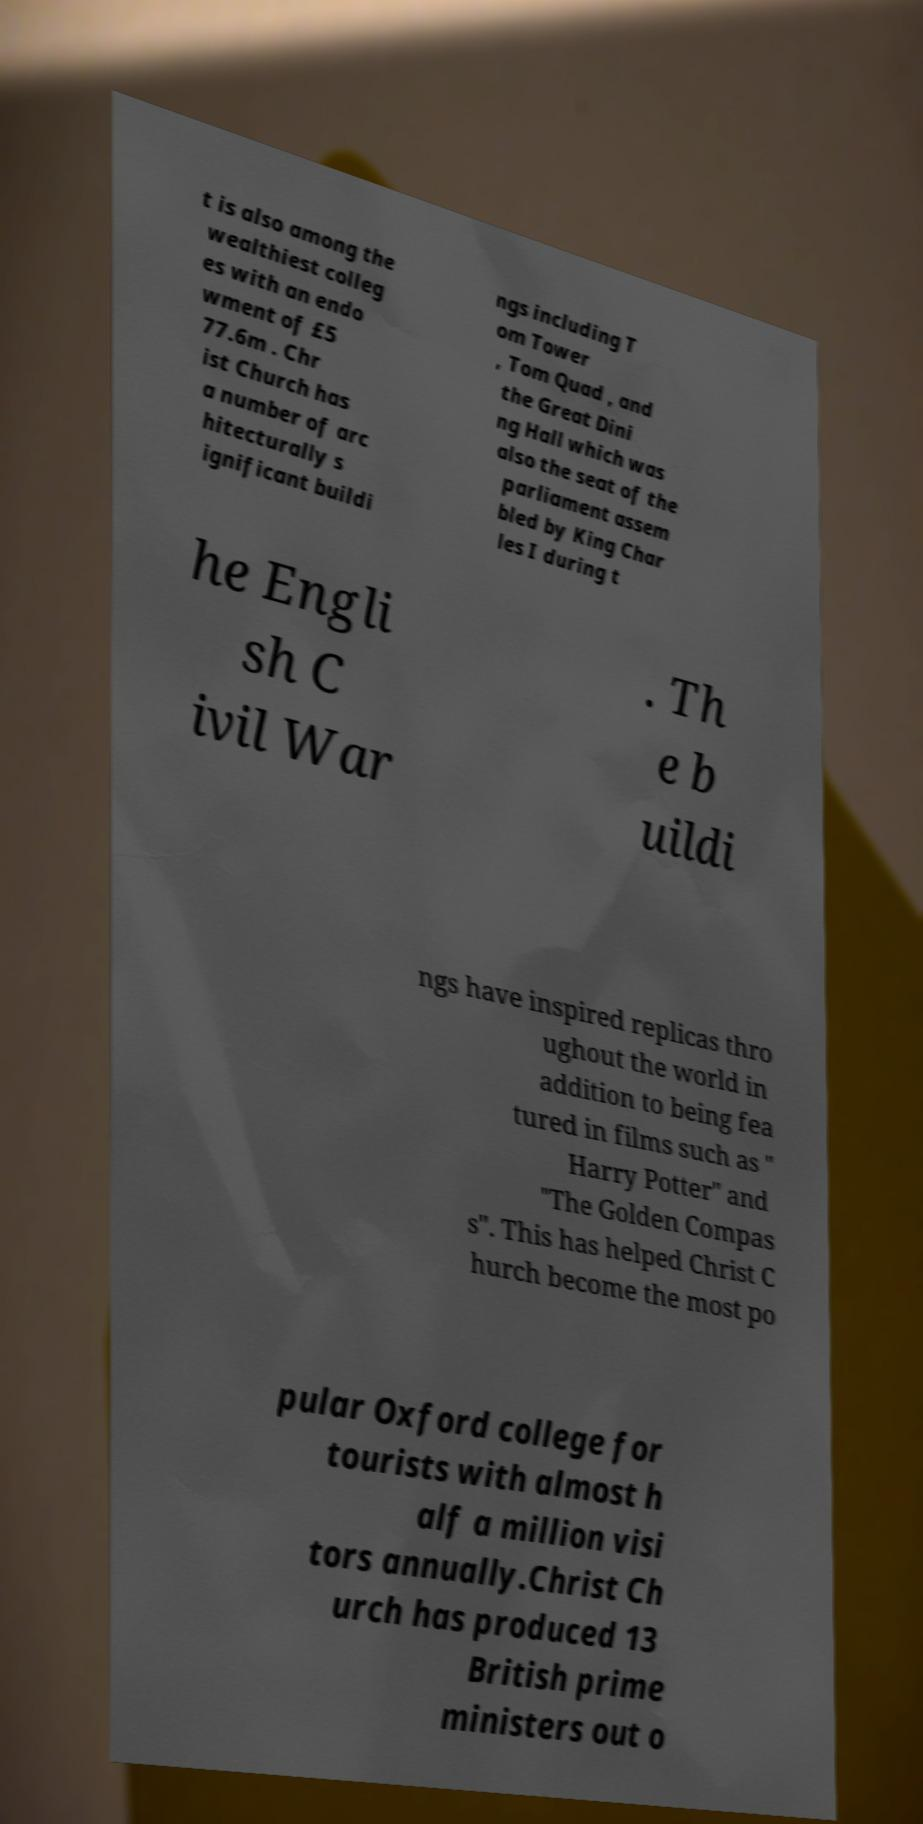Please identify and transcribe the text found in this image. t is also among the wealthiest colleg es with an endo wment of £5 77.6m . Chr ist Church has a number of arc hitecturally s ignificant buildi ngs including T om Tower , Tom Quad , and the Great Dini ng Hall which was also the seat of the parliament assem bled by King Char les I during t he Engli sh C ivil War . Th e b uildi ngs have inspired replicas thro ughout the world in addition to being fea tured in films such as " Harry Potter" and "The Golden Compas s". This has helped Christ C hurch become the most po pular Oxford college for tourists with almost h alf a million visi tors annually.Christ Ch urch has produced 13 British prime ministers out o 